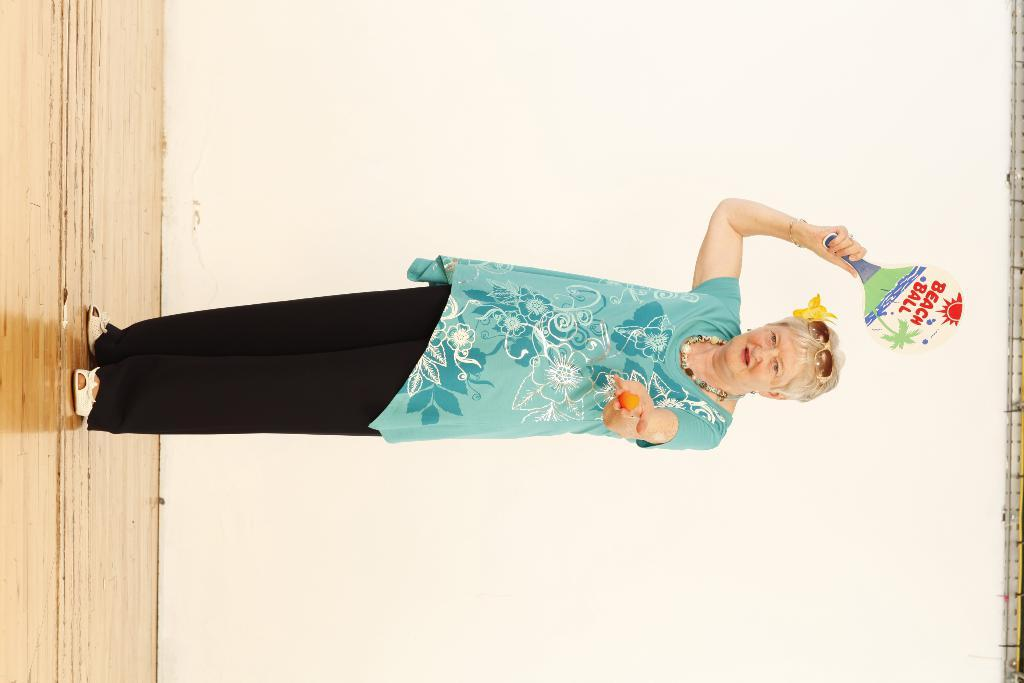Who is present in the image? There is a woman in the image. What is the woman doing in the image? The woman is standing on the floor. What accessory is the woman wearing in the image? The woman is wearing glasses. What can be seen in the background of the image? There is a wall in the background of the image. What type of ink is the woman using to write on the bushes in the image? There are no bushes or ink present in the image. The woman is not writing on anything. 